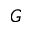<formula> <loc_0><loc_0><loc_500><loc_500>_ { G }</formula> 